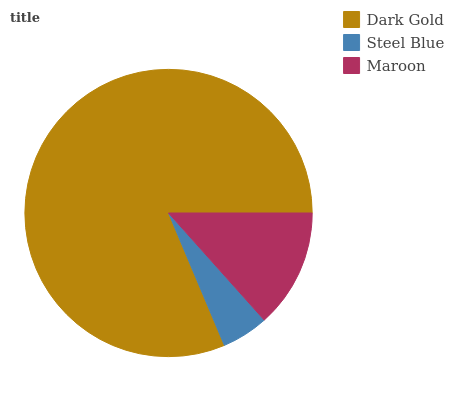Is Steel Blue the minimum?
Answer yes or no. Yes. Is Dark Gold the maximum?
Answer yes or no. Yes. Is Maroon the minimum?
Answer yes or no. No. Is Maroon the maximum?
Answer yes or no. No. Is Maroon greater than Steel Blue?
Answer yes or no. Yes. Is Steel Blue less than Maroon?
Answer yes or no. Yes. Is Steel Blue greater than Maroon?
Answer yes or no. No. Is Maroon less than Steel Blue?
Answer yes or no. No. Is Maroon the high median?
Answer yes or no. Yes. Is Maroon the low median?
Answer yes or no. Yes. Is Steel Blue the high median?
Answer yes or no. No. Is Steel Blue the low median?
Answer yes or no. No. 